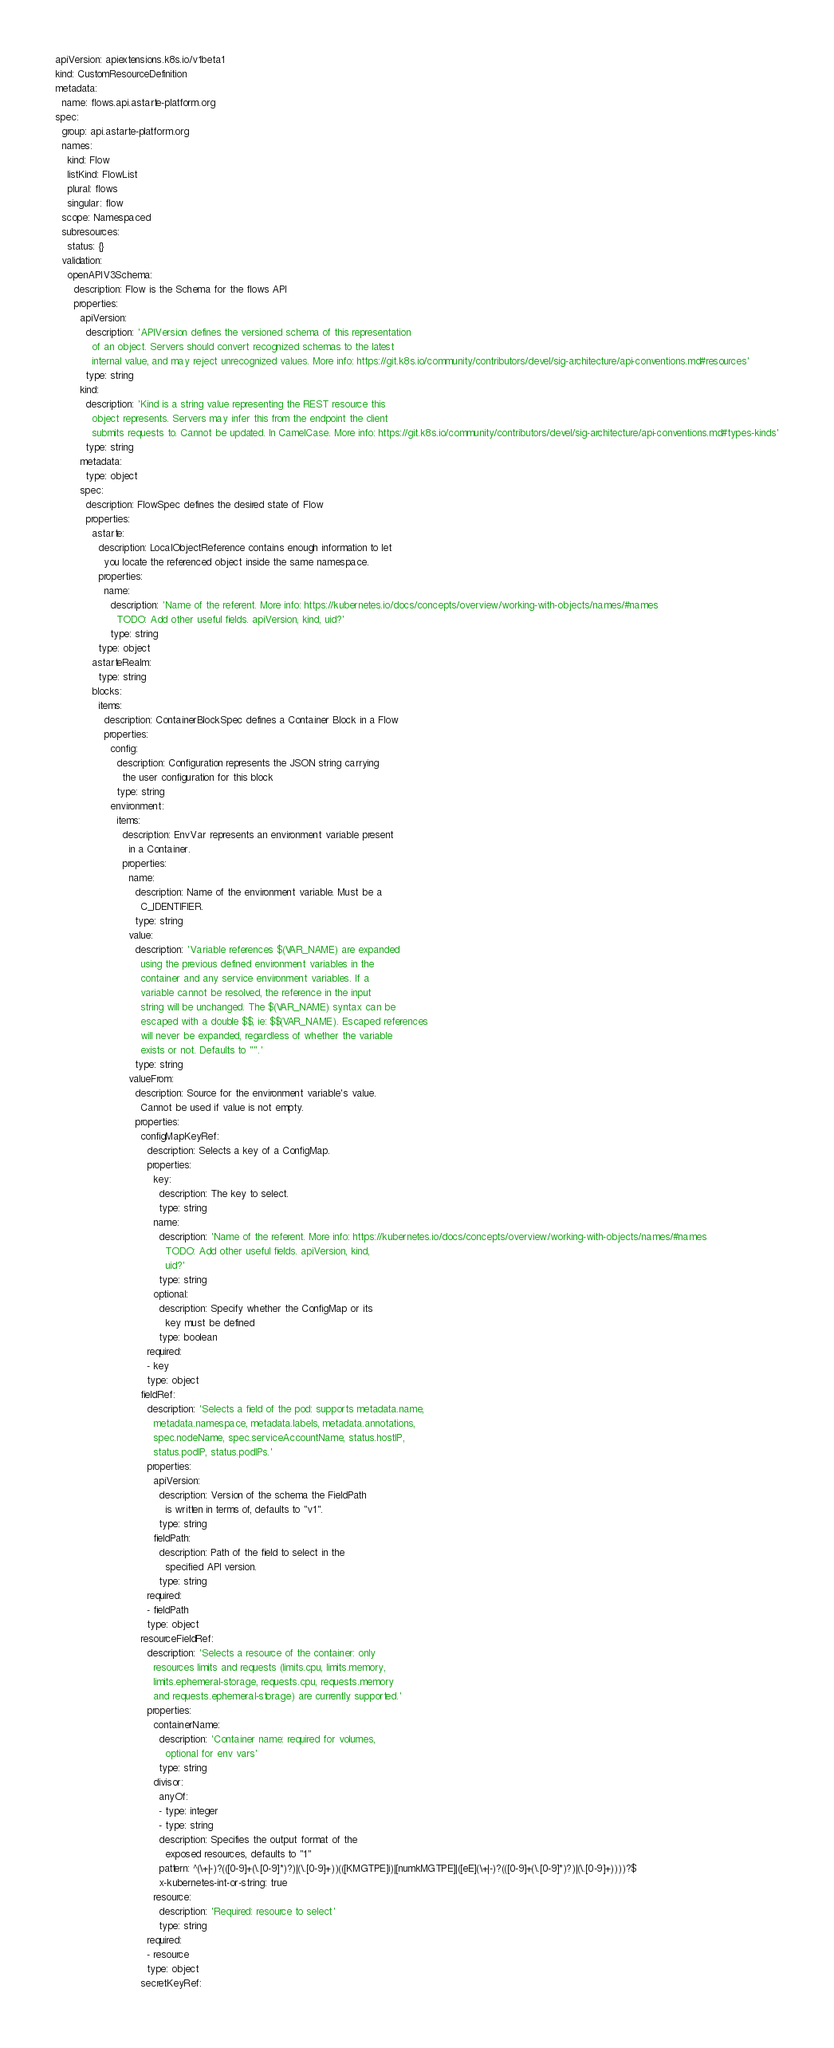<code> <loc_0><loc_0><loc_500><loc_500><_YAML_>apiVersion: apiextensions.k8s.io/v1beta1
kind: CustomResourceDefinition
metadata:
  name: flows.api.astarte-platform.org
spec:
  group: api.astarte-platform.org
  names:
    kind: Flow
    listKind: FlowList
    plural: flows
    singular: flow
  scope: Namespaced
  subresources:
    status: {}
  validation:
    openAPIV3Schema:
      description: Flow is the Schema for the flows API
      properties:
        apiVersion:
          description: 'APIVersion defines the versioned schema of this representation
            of an object. Servers should convert recognized schemas to the latest
            internal value, and may reject unrecognized values. More info: https://git.k8s.io/community/contributors/devel/sig-architecture/api-conventions.md#resources'
          type: string
        kind:
          description: 'Kind is a string value representing the REST resource this
            object represents. Servers may infer this from the endpoint the client
            submits requests to. Cannot be updated. In CamelCase. More info: https://git.k8s.io/community/contributors/devel/sig-architecture/api-conventions.md#types-kinds'
          type: string
        metadata:
          type: object
        spec:
          description: FlowSpec defines the desired state of Flow
          properties:
            astarte:
              description: LocalObjectReference contains enough information to let
                you locate the referenced object inside the same namespace.
              properties:
                name:
                  description: 'Name of the referent. More info: https://kubernetes.io/docs/concepts/overview/working-with-objects/names/#names
                    TODO: Add other useful fields. apiVersion, kind, uid?'
                  type: string
              type: object
            astarteRealm:
              type: string
            blocks:
              items:
                description: ContainerBlockSpec defines a Container Block in a Flow
                properties:
                  config:
                    description: Configuration represents the JSON string carrying
                      the user configuration for this block
                    type: string
                  environment:
                    items:
                      description: EnvVar represents an environment variable present
                        in a Container.
                      properties:
                        name:
                          description: Name of the environment variable. Must be a
                            C_IDENTIFIER.
                          type: string
                        value:
                          description: 'Variable references $(VAR_NAME) are expanded
                            using the previous defined environment variables in the
                            container and any service environment variables. If a
                            variable cannot be resolved, the reference in the input
                            string will be unchanged. The $(VAR_NAME) syntax can be
                            escaped with a double $$, ie: $$(VAR_NAME). Escaped references
                            will never be expanded, regardless of whether the variable
                            exists or not. Defaults to "".'
                          type: string
                        valueFrom:
                          description: Source for the environment variable's value.
                            Cannot be used if value is not empty.
                          properties:
                            configMapKeyRef:
                              description: Selects a key of a ConfigMap.
                              properties:
                                key:
                                  description: The key to select.
                                  type: string
                                name:
                                  description: 'Name of the referent. More info: https://kubernetes.io/docs/concepts/overview/working-with-objects/names/#names
                                    TODO: Add other useful fields. apiVersion, kind,
                                    uid?'
                                  type: string
                                optional:
                                  description: Specify whether the ConfigMap or its
                                    key must be defined
                                  type: boolean
                              required:
                              - key
                              type: object
                            fieldRef:
                              description: 'Selects a field of the pod: supports metadata.name,
                                metadata.namespace, metadata.labels, metadata.annotations,
                                spec.nodeName, spec.serviceAccountName, status.hostIP,
                                status.podIP, status.podIPs.'
                              properties:
                                apiVersion:
                                  description: Version of the schema the FieldPath
                                    is written in terms of, defaults to "v1".
                                  type: string
                                fieldPath:
                                  description: Path of the field to select in the
                                    specified API version.
                                  type: string
                              required:
                              - fieldPath
                              type: object
                            resourceFieldRef:
                              description: 'Selects a resource of the container: only
                                resources limits and requests (limits.cpu, limits.memory,
                                limits.ephemeral-storage, requests.cpu, requests.memory
                                and requests.ephemeral-storage) are currently supported.'
                              properties:
                                containerName:
                                  description: 'Container name: required for volumes,
                                    optional for env vars'
                                  type: string
                                divisor:
                                  anyOf:
                                  - type: integer
                                  - type: string
                                  description: Specifies the output format of the
                                    exposed resources, defaults to "1"
                                  pattern: ^(\+|-)?(([0-9]+(\.[0-9]*)?)|(\.[0-9]+))(([KMGTPE]i)|[numkMGTPE]|([eE](\+|-)?(([0-9]+(\.[0-9]*)?)|(\.[0-9]+))))?$
                                  x-kubernetes-int-or-string: true
                                resource:
                                  description: 'Required: resource to select'
                                  type: string
                              required:
                              - resource
                              type: object
                            secretKeyRef:</code> 